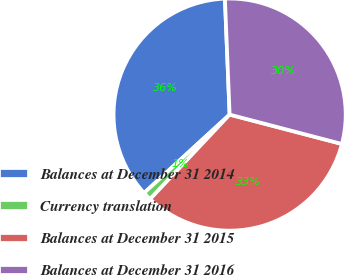Convert chart to OTSL. <chart><loc_0><loc_0><loc_500><loc_500><pie_chart><fcel>Balances at December 31 2014<fcel>Currency translation<fcel>Balances at December 31 2015<fcel>Balances at December 31 2016<nl><fcel>36.16%<fcel>1.18%<fcel>32.94%<fcel>29.72%<nl></chart> 